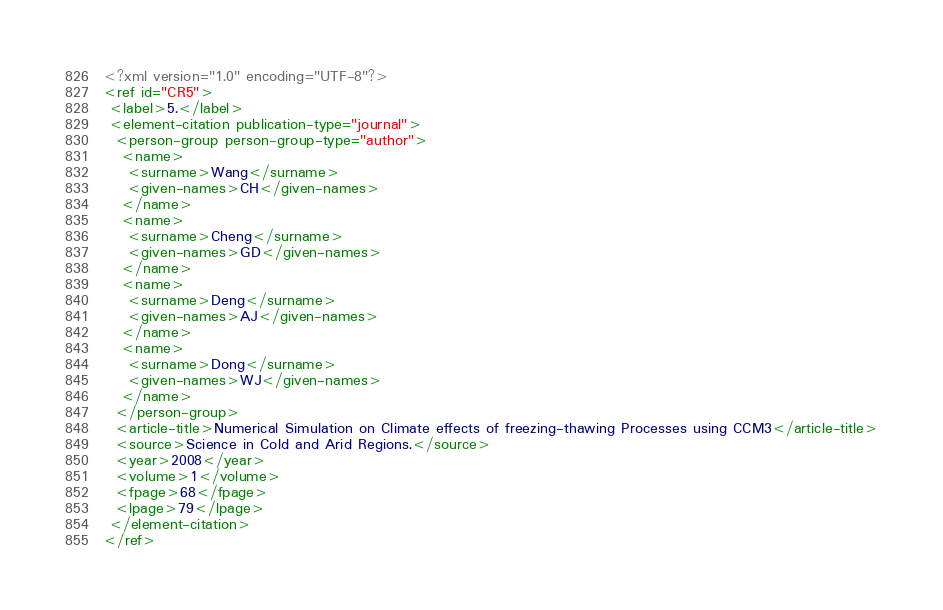Convert code to text. <code><loc_0><loc_0><loc_500><loc_500><_XML_><?xml version="1.0" encoding="UTF-8"?>
<ref id="CR5">
 <label>5.</label>
 <element-citation publication-type="journal">
  <person-group person-group-type="author">
   <name>
    <surname>Wang</surname>
    <given-names>CH</given-names>
   </name>
   <name>
    <surname>Cheng</surname>
    <given-names>GD</given-names>
   </name>
   <name>
    <surname>Deng</surname>
    <given-names>AJ</given-names>
   </name>
   <name>
    <surname>Dong</surname>
    <given-names>WJ</given-names>
   </name>
  </person-group>
  <article-title>Numerical Simulation on Climate effects of freezing-thawing Processes using CCM3</article-title>
  <source>Science in Cold and Arid Regions.</source>
  <year>2008</year>
  <volume>1</volume>
  <fpage>68</fpage>
  <lpage>79</lpage>
 </element-citation>
</ref>
</code> 